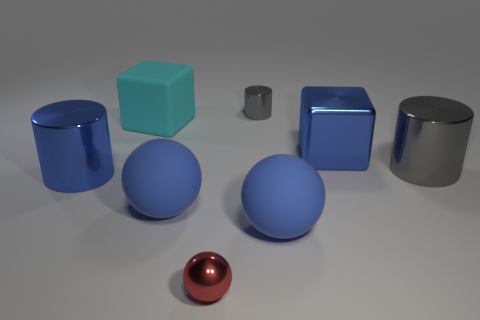There is a thing that is the same color as the small metallic cylinder; what is its shape?
Offer a terse response. Cylinder. What is the shape of the tiny red thing that is the same material as the big gray thing?
Ensure brevity in your answer.  Sphere. What size is the blue shiny thing that is to the left of the large blue matte ball that is left of the metal ball?
Make the answer very short. Large. What number of things are large blue shiny things in front of the metal cube or large cylinders left of the small cylinder?
Make the answer very short. 1. Is the number of small red metallic objects less than the number of large spheres?
Provide a succinct answer. Yes. How many objects are tiny cyan metallic balls or gray things?
Ensure brevity in your answer.  2. Does the cyan matte thing have the same shape as the tiny gray object?
Your answer should be compact. No. Do the gray metallic cylinder behind the big gray cylinder and the cylinder to the left of the tiny cylinder have the same size?
Offer a terse response. No. There is a cylinder that is on the left side of the large gray thing and in front of the small shiny cylinder; what material is it?
Make the answer very short. Metal. Is there any other thing of the same color as the small cylinder?
Provide a short and direct response. Yes. 